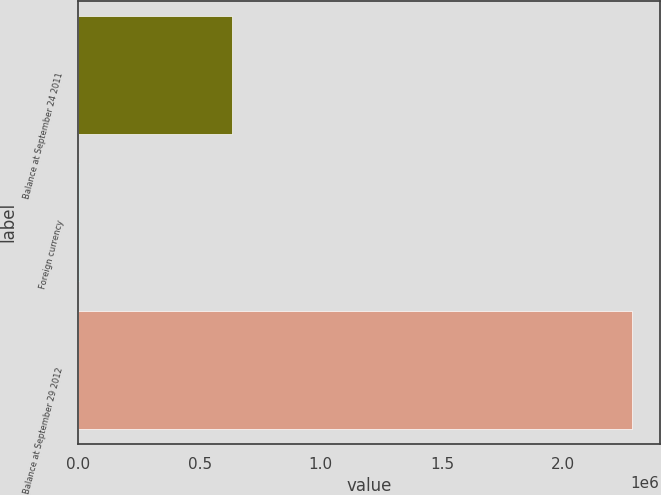<chart> <loc_0><loc_0><loc_500><loc_500><bar_chart><fcel>Balance at September 24 2011<fcel>Foreign currency<fcel>Balance at September 29 2012<nl><fcel>633319<fcel>907<fcel>2.28345e+06<nl></chart> 